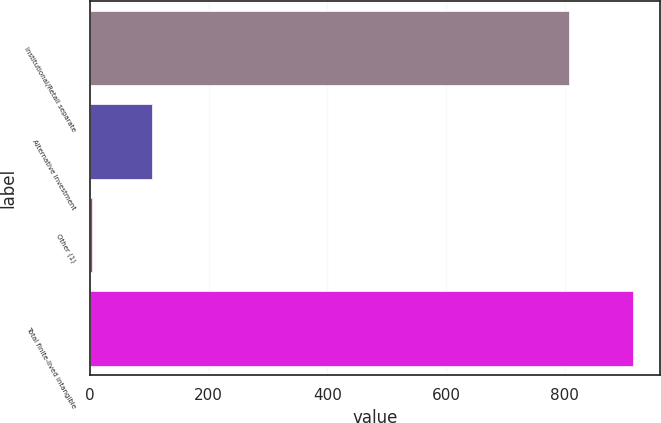Convert chart to OTSL. <chart><loc_0><loc_0><loc_500><loc_500><bar_chart><fcel>Institutional/Retail separate<fcel>Alternative investment<fcel>Other (1)<fcel>Total finite-lived intangible<nl><fcel>807<fcel>104<fcel>4<fcel>915<nl></chart> 